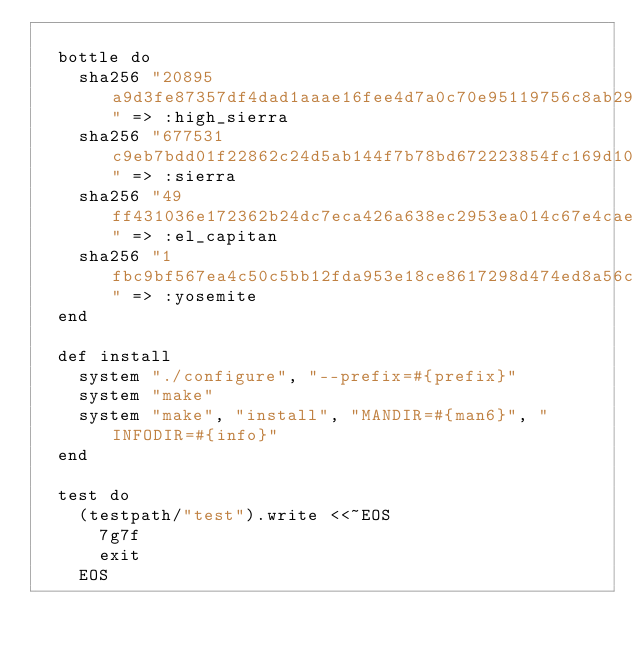Convert code to text. <code><loc_0><loc_0><loc_500><loc_500><_Ruby_>
  bottle do
    sha256 "20895a9d3fe87357df4dad1aaae16fee4d7a0c70e95119756c8ab2928817c161" => :high_sierra
    sha256 "677531c9eb7bdd01f22862c24d5ab144f7b78bd672223854fc169d103a9924e2" => :sierra
    sha256 "49ff431036e172362b24dc7eca426a638ec2953ea014c67e4cae239e9175bf27" => :el_capitan
    sha256 "1fbc9bf567ea4c50c5bb12fda953e18ce8617298d474ed8a56ca2b9dd24b2726" => :yosemite
  end

  def install
    system "./configure", "--prefix=#{prefix}"
    system "make"
    system "make", "install", "MANDIR=#{man6}", "INFODIR=#{info}"
  end

  test do
    (testpath/"test").write <<~EOS
      7g7f
      exit
    EOS</code> 